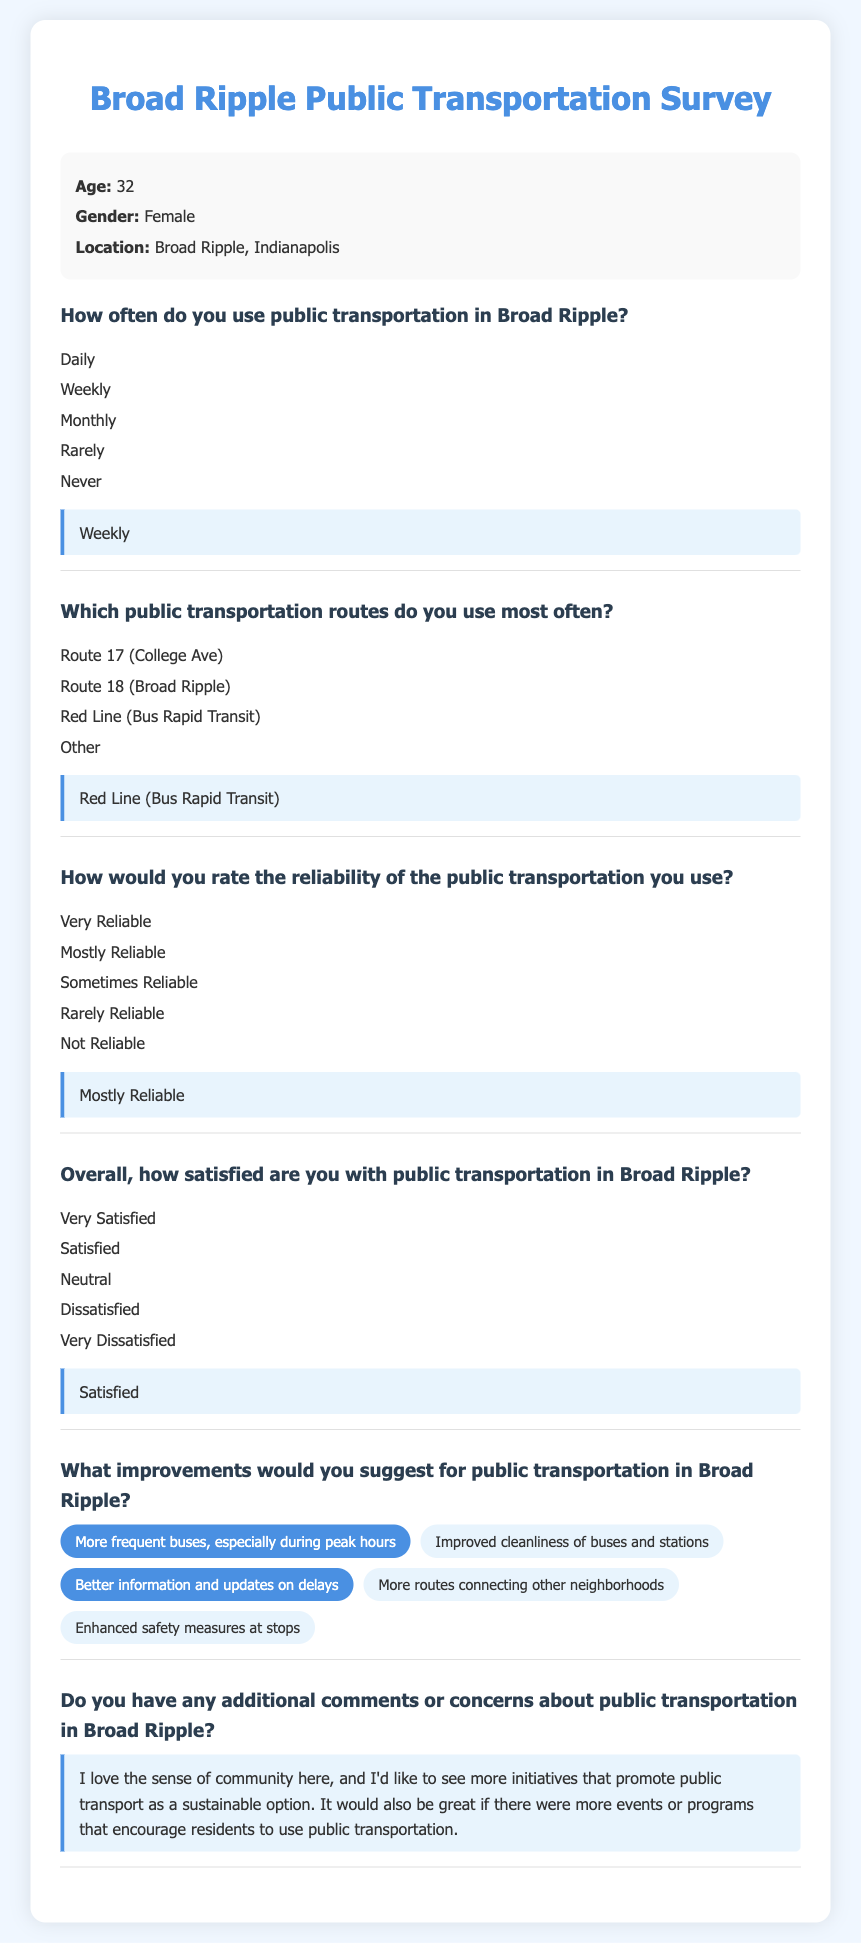How often does the resident use public transportation? The answer indicates the resident uses public transportation on a weekly basis.
Answer: Weekly Which public transportation route does the resident use most often? The response specifies that the resident frequently utilizes the Red Line for bus rapid transit.
Answer: Red Line (Bus Rapid Transit) How does the resident rate the reliability of the public transportation? The resident expresses that they find the public transportation to be mostly reliable.
Answer: Mostly Reliable What is the overall satisfaction level of the resident with public transportation? The resident's overall satisfaction is categorized as satisfied.
Answer: Satisfied What improvement suggestion did the resident make regarding public transportation? The resident suggested more frequent buses, especially during peak hours, as an improvement.
Answer: More frequent buses, especially during peak hours What additional comments does the resident have about public transportation? The resident commented on their love for the community and desire for initiatives promoting public transport.
Answer: I love the sense of community here, and I'd like to see more initiatives that promote public transport as a sustainable option 